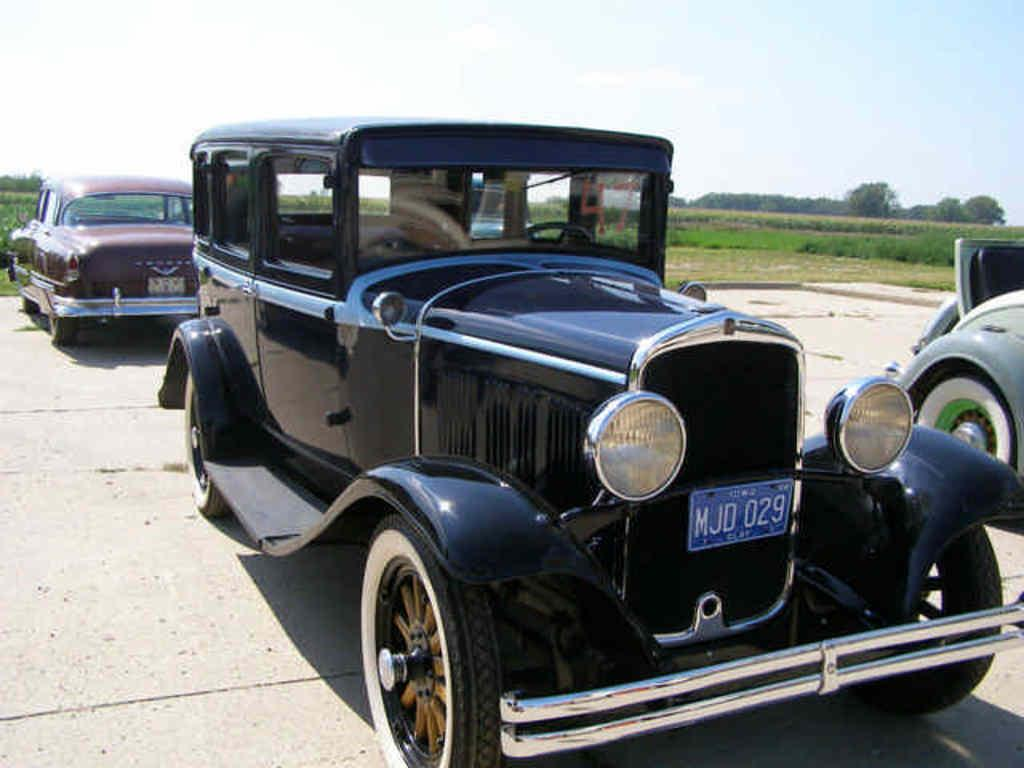What can be seen in the foreground of the image? There are three vehicles in the foreground of the image. Are the vehicles elevated or on the ground? The vehicles are on the ground. What type of environment is visible in the background of the image? There is greenery in the background of the image. What is visible at the top of the image? The sky is visible at the top of the image. How many babies are sitting on the brick in the image? There is no brick or babies present in the image. What type of writing can be seen on the vehicles in the image? The provided facts do not mention any writing on the vehicles, so it cannot be determined from the image. 